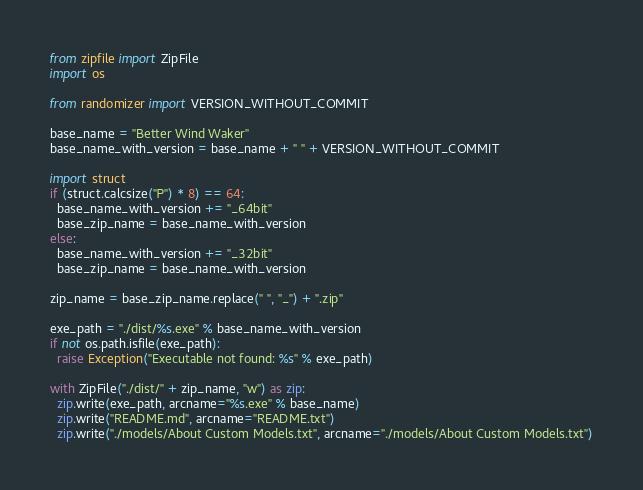<code> <loc_0><loc_0><loc_500><loc_500><_Python_>
from zipfile import ZipFile
import os

from randomizer import VERSION_WITHOUT_COMMIT

base_name = "Better Wind Waker"
base_name_with_version = base_name + " " + VERSION_WITHOUT_COMMIT

import struct
if (struct.calcsize("P") * 8) == 64:
  base_name_with_version += "_64bit"
  base_zip_name = base_name_with_version
else:
  base_name_with_version += "_32bit"
  base_zip_name = base_name_with_version

zip_name = base_zip_name.replace(" ", "_") + ".zip"

exe_path = "./dist/%s.exe" % base_name_with_version
if not os.path.isfile(exe_path):
  raise Exception("Executable not found: %s" % exe_path)

with ZipFile("./dist/" + zip_name, "w") as zip:
  zip.write(exe_path, arcname="%s.exe" % base_name)
  zip.write("README.md", arcname="README.txt")
  zip.write("./models/About Custom Models.txt", arcname="./models/About Custom Models.txt")
</code> 